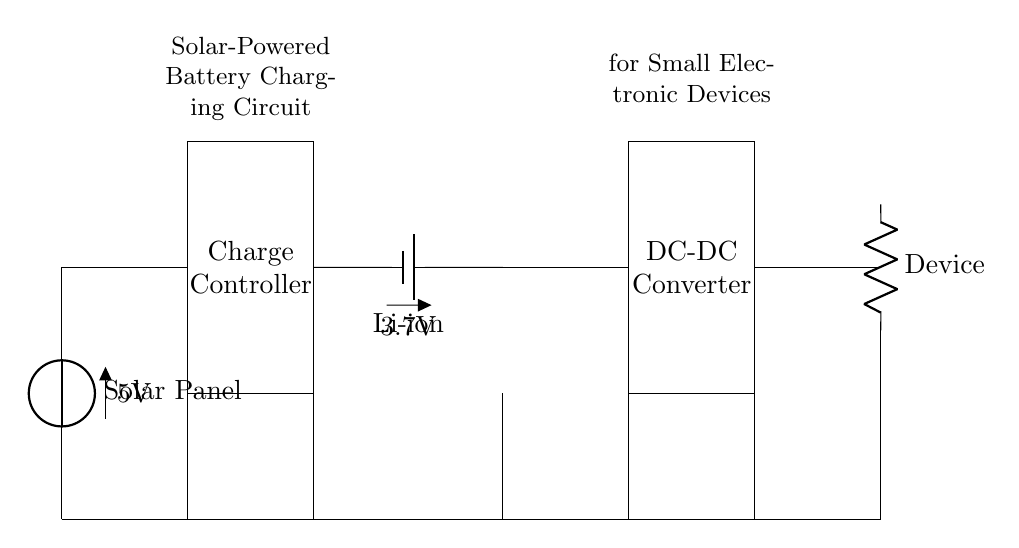What is the voltage of the solar panel? The voltage of the solar panel is marked as 5V in the diagram, indicating the output voltage provided by the solar panel component.
Answer: 5V What type of battery is used in this circuit? The circuit diagram specifies a lithium-ion (Li-ion) battery, which is indicated next to the battery symbol in the diagram.
Answer: Li-ion How many main components are there in this circuit? The diagram shows five main components: Solar Panel, Charge Controller, Battery, DC-DC Converter, and Output Device, totaling five distinct elements.
Answer: 5 What is the voltage of the battery? The voltage of the battery is indicated as 3.7V in the diagram, which represents the nominal voltage output of the lithium-ion battery.
Answer: 3.7V What is the purpose of the DC-DC converter? The DC-DC converter's role is to adjust the voltage output, which allows for compatibility with various devices or battery charging requirements specifically in this solar charging context.
Answer: To adjust voltage Why is a charge controller necessary in this circuit? A charge controller is required to regulate the charging of the battery, preventing overcharging and ensuring the safe operation of the circuit overall, particularly in a solar-powered application.
Answer: To prevent overcharging 